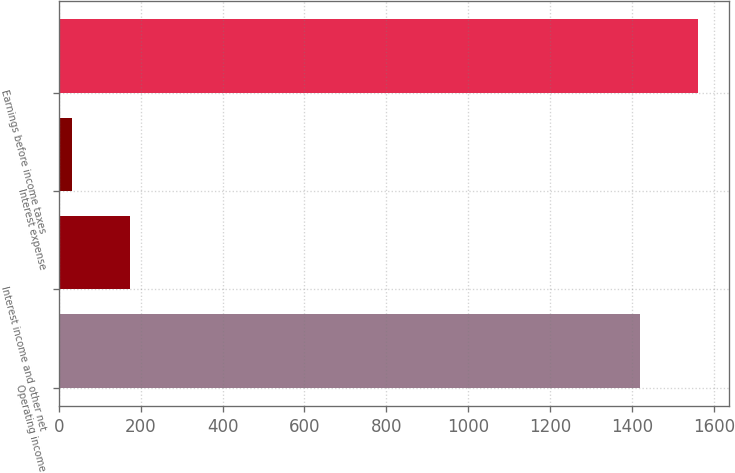Convert chart to OTSL. <chart><loc_0><loc_0><loc_500><loc_500><bar_chart><fcel>Operating income<fcel>Interest income and other net<fcel>Interest expense<fcel>Earnings before income taxes<nl><fcel>1419.4<fcel>173.13<fcel>32.7<fcel>1559.83<nl></chart> 